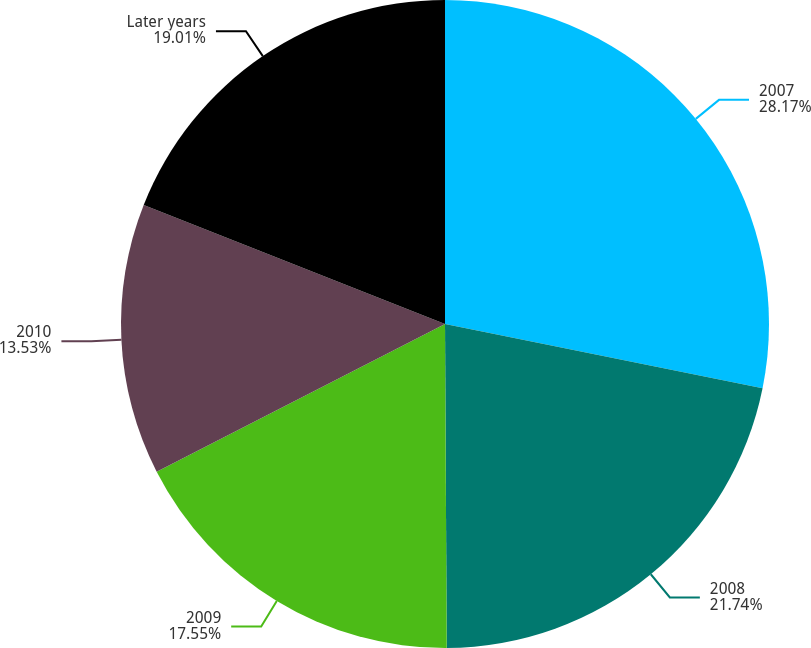Convert chart to OTSL. <chart><loc_0><loc_0><loc_500><loc_500><pie_chart><fcel>2007<fcel>2008<fcel>2009<fcel>2010<fcel>Later years<nl><fcel>28.18%<fcel>21.74%<fcel>17.55%<fcel>13.53%<fcel>19.01%<nl></chart> 